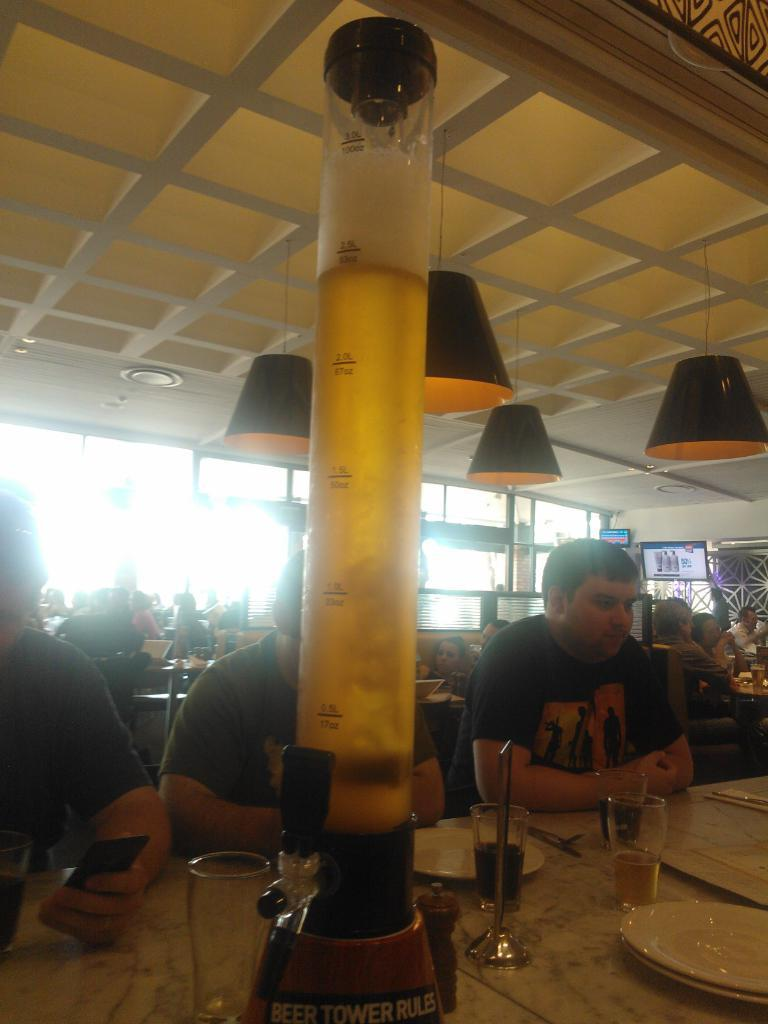How many people are in the image? There is a group of people in the image, but the exact number cannot be determined from the provided facts. What can be seen in the image besides the people? There are lights, chairs, tables, glasses, and white color plates visible in the image. What might the people be using the chairs and tables for? The chairs and tables suggest that the people might be sitting down for a meal or gathering. What is on the table in the image? There are glasses and white color plates on the table. What type of ice can be seen melting on the wing of the airplane in the image? There is no airplane or ice present in the image; it features a group of people, lights, chairs, tables, glasses, and white color plates. 